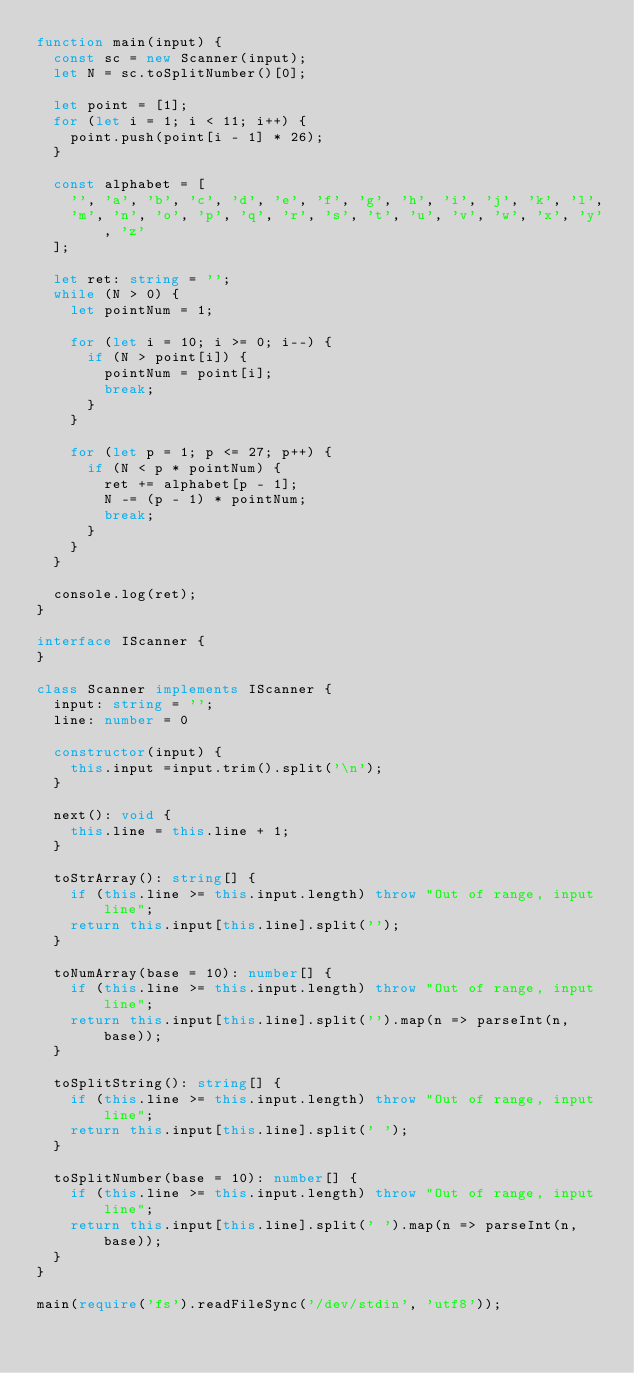Convert code to text. <code><loc_0><loc_0><loc_500><loc_500><_TypeScript_>function main(input) {
  const sc = new Scanner(input);
  let N = sc.toSplitNumber()[0];

  let point = [1];
  for (let i = 1; i < 11; i++) {
    point.push(point[i - 1] * 26);
  }

  const alphabet = [
    '', 'a', 'b', 'c', 'd', 'e', 'f', 'g', 'h', 'i', 'j', 'k', 'l',
    'm', 'n', 'o', 'p', 'q', 'r', 's', 't', 'u', 'v', 'w', 'x', 'y', 'z'
  ];

  let ret: string = '';
  while (N > 0) {
    let pointNum = 1;

    for (let i = 10; i >= 0; i--) {
      if (N > point[i]) {
        pointNum = point[i];
        break;
      }
    }

    for (let p = 1; p <= 27; p++) {
      if (N < p * pointNum) {
        ret += alphabet[p - 1];
        N -= (p - 1) * pointNum;
        break;
      }
    }
  }

  console.log(ret);
}

interface IScanner {
}

class Scanner implements IScanner {
  input: string = '';
  line: number = 0

  constructor(input) {
    this.input =input.trim().split('\n');
  }

  next(): void {
    this.line = this.line + 1;
  }

  toStrArray(): string[] {
    if (this.line >= this.input.length) throw "Out of range, input line";
    return this.input[this.line].split('');
  }

  toNumArray(base = 10): number[] {
    if (this.line >= this.input.length) throw "Out of range, input line";
    return this.input[this.line].split('').map(n => parseInt(n, base));
  }

  toSplitString(): string[] {
    if (this.line >= this.input.length) throw "Out of range, input line";
    return this.input[this.line].split(' ');
  }

  toSplitNumber(base = 10): number[] {
    if (this.line >= this.input.length) throw "Out of range, input line";
    return this.input[this.line].split(' ').map(n => parseInt(n, base));
  }
}

main(require('fs').readFileSync('/dev/stdin', 'utf8'));
</code> 